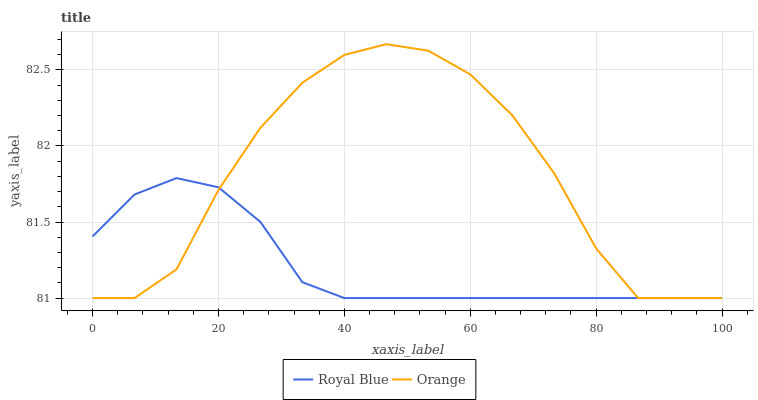Does Royal Blue have the minimum area under the curve?
Answer yes or no. Yes. Does Orange have the maximum area under the curve?
Answer yes or no. Yes. Does Royal Blue have the maximum area under the curve?
Answer yes or no. No. Is Royal Blue the smoothest?
Answer yes or no. Yes. Is Orange the roughest?
Answer yes or no. Yes. Is Royal Blue the roughest?
Answer yes or no. No. Does Orange have the highest value?
Answer yes or no. Yes. Does Royal Blue have the highest value?
Answer yes or no. No. Does Orange intersect Royal Blue?
Answer yes or no. Yes. Is Orange less than Royal Blue?
Answer yes or no. No. Is Orange greater than Royal Blue?
Answer yes or no. No. 